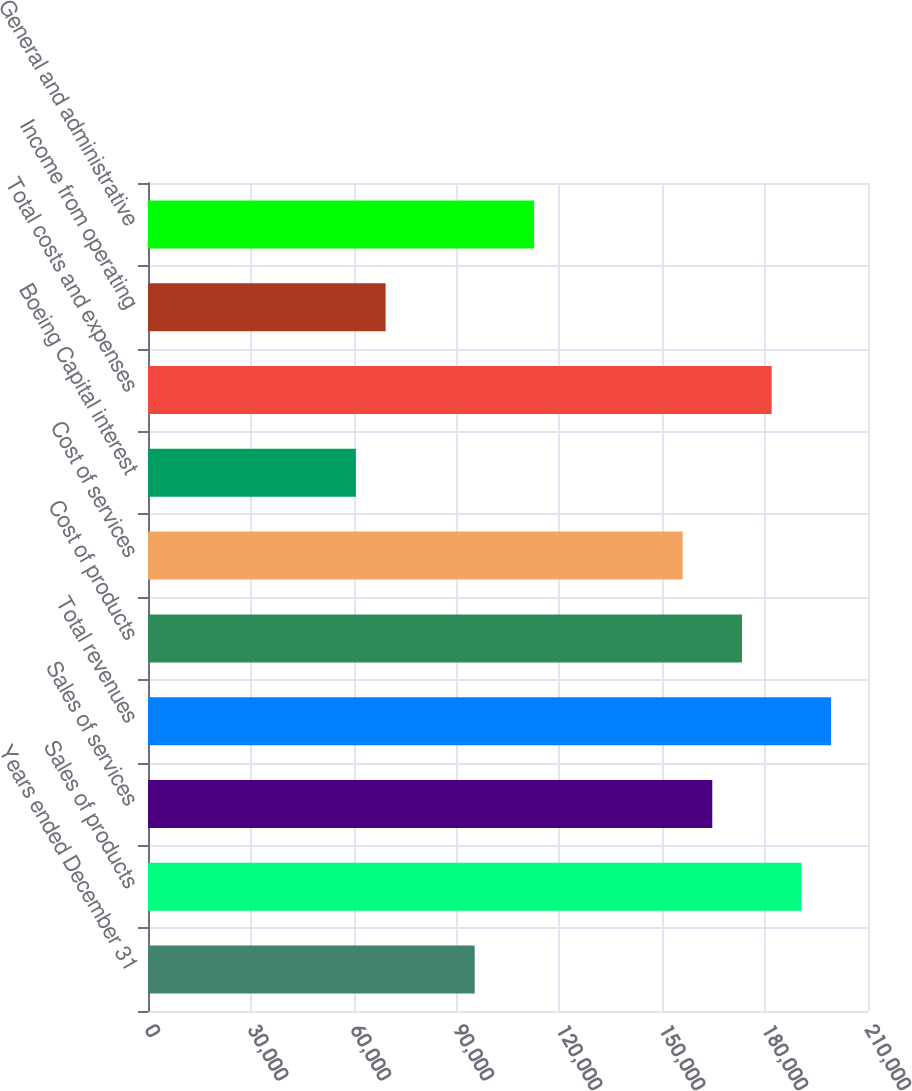Convert chart. <chart><loc_0><loc_0><loc_500><loc_500><bar_chart><fcel>Years ended December 31<fcel>Sales of products<fcel>Sales of services<fcel>Total revenues<fcel>Cost of products<fcel>Cost of services<fcel>Boeing Capital interest<fcel>Total costs and expenses<fcel>Income from operating<fcel>General and administrative<nl><fcel>95285.2<fcel>190569<fcel>164583<fcel>199232<fcel>173245<fcel>155921<fcel>60636.4<fcel>181907<fcel>69298.6<fcel>112610<nl></chart> 